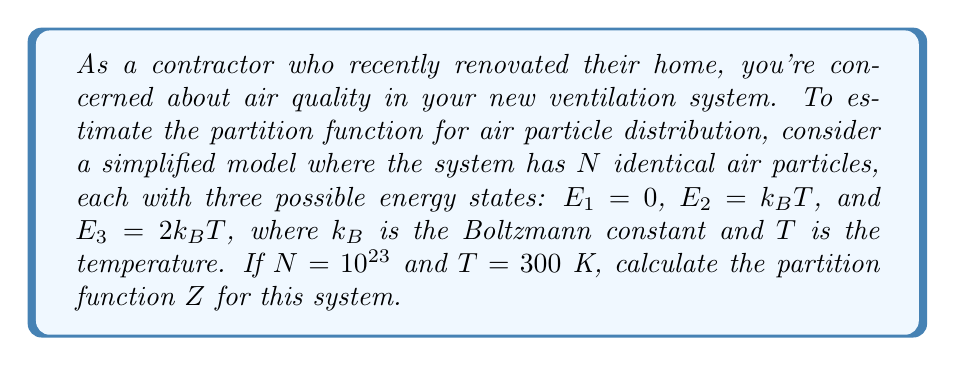Solve this math problem. To solve this problem, we'll follow these steps:

1) The partition function $Z$ for a system of $N$ independent particles is given by:

   $$Z = (z)^N$$

   where $z$ is the partition function for a single particle.

2) For a single particle with discrete energy levels, the partition function is:

   $$z = \sum_i e^{-\beta E_i}$$

   where $\beta = \frac{1}{k_BT}$ and $E_i$ are the possible energy states.

3) In this case, we have three energy states:
   $E_1 = 0$, $E_2 = k_BT$, and $E_3 = 2k_BT$

4) Let's calculate $z$:

   $$z = e^{-\beta E_1} + e^{-\beta E_2} + e^{-\beta E_3}$$
   $$z = e^{-\beta \cdot 0} + e^{-\beta \cdot k_BT} + e^{-\beta \cdot 2k_BT}$$
   $$z = 1 + e^{-1} + e^{-2}$$

5) Now we can calculate the numerical value:
   
   $$z = 1 + \frac{1}{e} + \frac{1}{e^2} \approx 1.7768$$

6) The total partition function is:

   $$Z = (1.7768)^{10^{23}}$$

7) This number is extremely large. We can express it in scientific notation:

   $$Z \approx 10^{1.77 \times 10^{23}}$$
Answer: $Z \approx 10^{1.77 \times 10^{23}}$ 